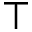Convert formula to latex. <formula><loc_0><loc_0><loc_500><loc_500>\top</formula> 